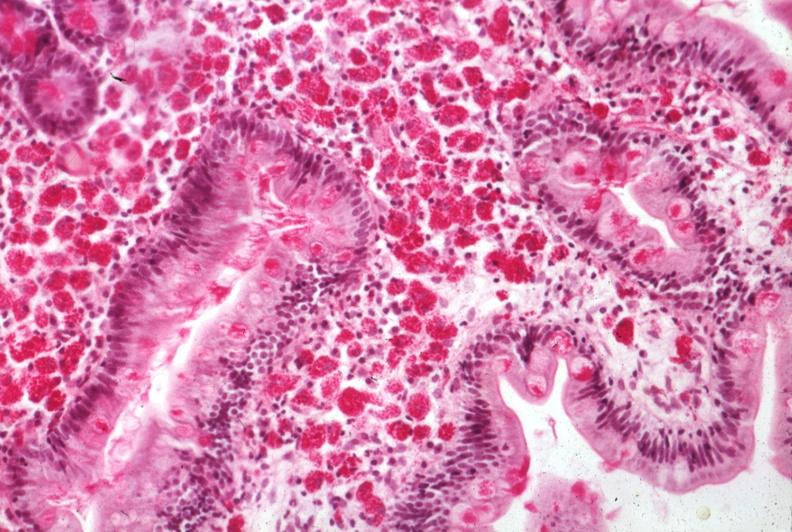s intestine present?
Answer the question using a single word or phrase. Yes 